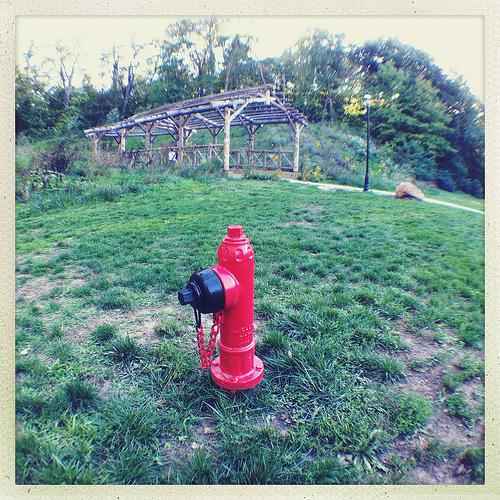Question: what is the focus of the photo?
Choices:
A. The fire.
B. The fire truck.
C. The fireman.
D. A fire hydrant.
Answer with the letter. Answer: D Question: what color is the fire hydrant?
Choices:
A. Yellow.
B. Red and black.
C. White.
D. Green.
Answer with the letter. Answer: B Question: where is he fire hydrant?
Choices:
A. On the sidewalk.
B. In the grass.
C. Near the street.
D. By the building.
Answer with the letter. Answer: B Question: what is in the background of the fire hydrant?
Choices:
A. A building.
B. A parking lot.
C. A park.
D. A bridge.
Answer with the letter. Answer: D Question: how would an individual reach the fire hydrant?
Choices:
A. Walk down the street.
B. Drive around the corner.
C. Walk from the trail.
D. Drive up the street.
Answer with the letter. Answer: C Question: where is this photo taken?
Choices:
A. Outside by a walking trail.
B. In the woods.
C. At the mountains.
D. By the lake.
Answer with the letter. Answer: A Question: what does the photo look like?
Choices:
A. A park.
B. A playground.
C. A backyard.
D. A garden.
Answer with the letter. Answer: A 